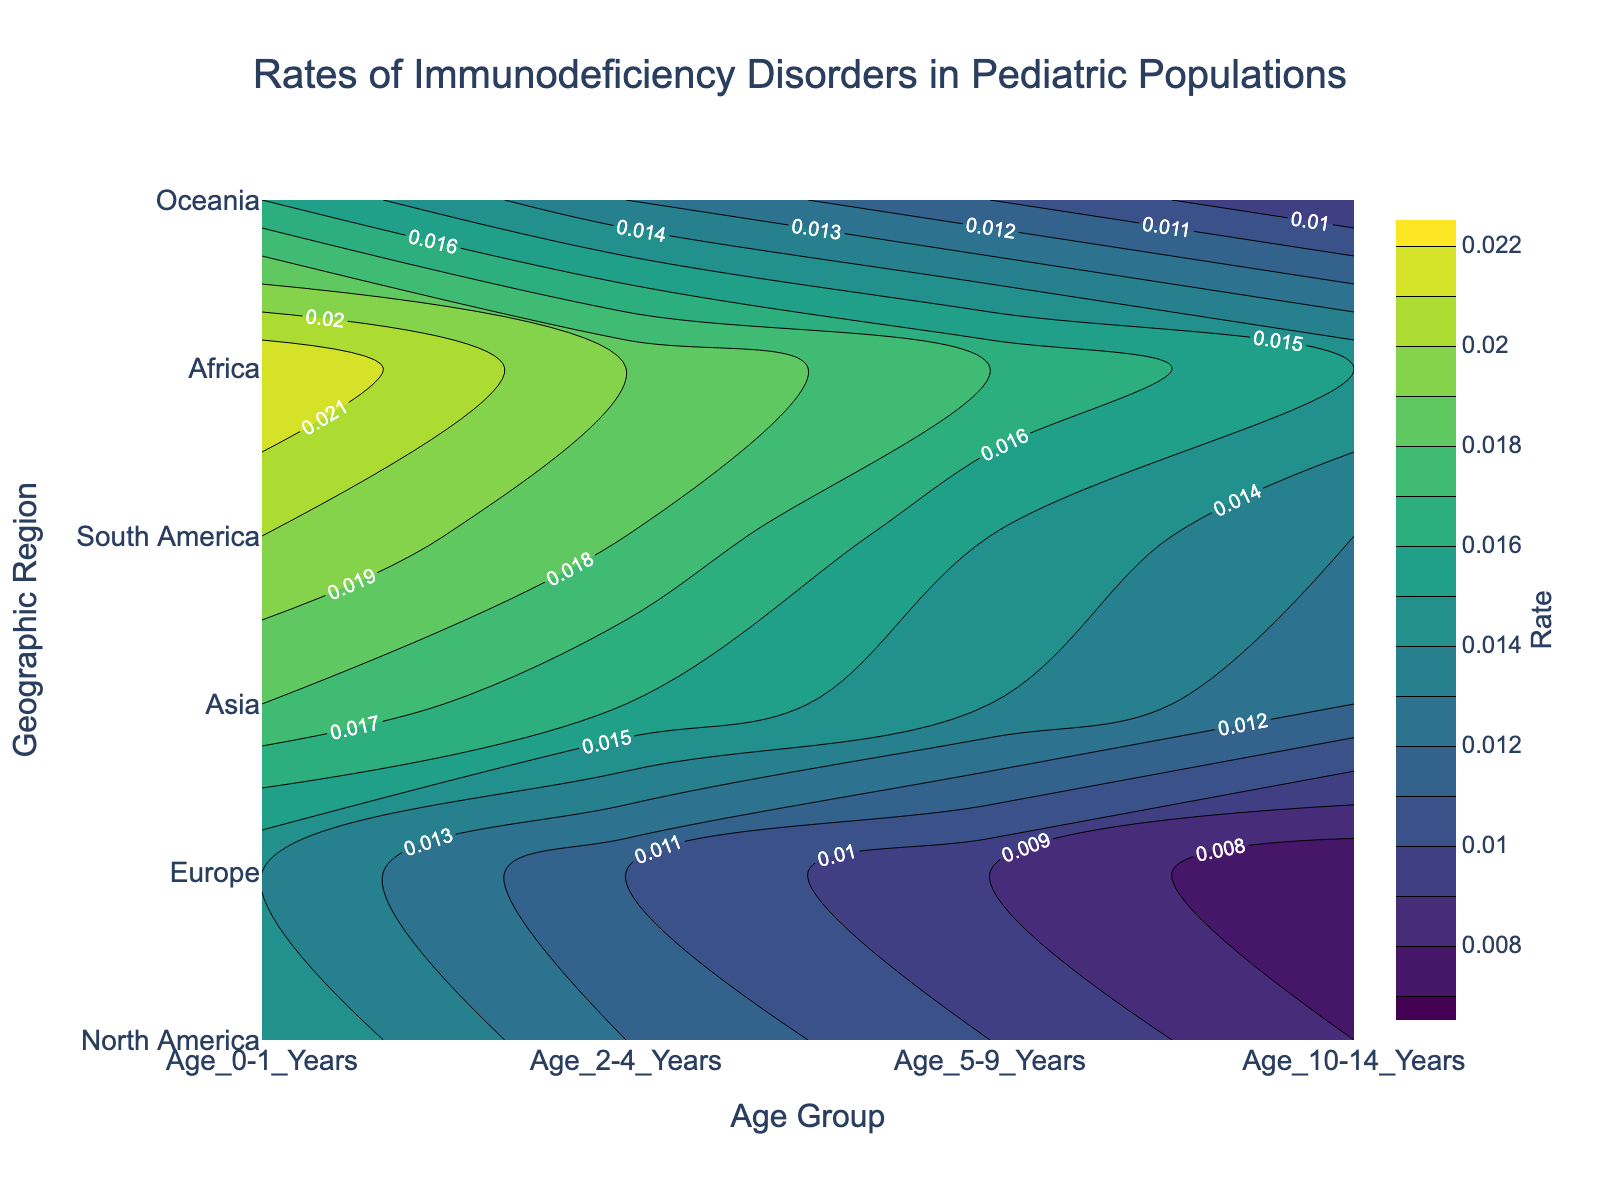What is the title of the figure? The title of a figure is usually placed at the top and is clearly labeled. Looking at the top of the figure, you can see "Rates of Immunodeficiency Disorders in Pediatric Populations."
Answer: Rates of Immunodeficiency Disorders in Pediatric Populations Which geographic region has the highest rate of immunodeficiency disorders for the age group 0-1 years? To determine this, look at the y-axis which lists the geographic regions and then identify the highest contour level closest to the age group "Age_0-1_Years" on the x-axis. Africa has the highest rate.
Answer: Africa Does Oceania have a higher rate of immunodeficiency disorders in the 5-9 years age group compared to North America in the same age group? Compare the rates for Oceania and North America in the 5-9 years age group by finding the contour levels along the respective rows for the "Age_5-9_Years" column. Oceania's rate (0.011) is higher than North America’s rate (0.010).
Answer: Yes What is the range of rates shown in the figure? The color bar on the right-hand side of the figure indicates the range of rates from the start to the end of the contour. The rates range from 0.007 to 0.022.
Answer: 0.007 to 0.022 How does the rate of immunodeficiency disorders change with age within Europe? Track Europe on the y-axis and follow the contour lines across the x-axis from "Age_0-1_Years" to "Age_10-14_Years." The rate decreases from 0.014 (Age 0-1 Years) to 0.007 (Age 10-14 Years).
Answer: It decreases Which age group shows the highest variance in rates across all regions? Variance can be assessed by looking at how spread out the contour lines are for each age group across all regions. The "Age_0-1_Years" group shows the largest range from 0.015 (North America) to 0.022 (Africa), indicating high variance.
Answer: Age_0-1_Years Does South America have a higher rate of immunodeficiency disorders for 2-4 years age group compared to Asia for 10-14 years age group? Compare the rates in the relevant contour levels: South America's 2-4 years rate (0.018) and Asia's 10-14 years rate (0.012). South America's rate is higher.
Answer: Yes What is the average rate of immunodeficiency disorders for the 10-14 years age group across all regions? Locate the rates for 10-14 years age group for each region and find the mean value. (0.008 + 0.007 + 0.012 + 0.013 + 0.015 + 0.009) / 6 = 0.064 / 6 ≈ 0.0107
Answer: 0.0107 